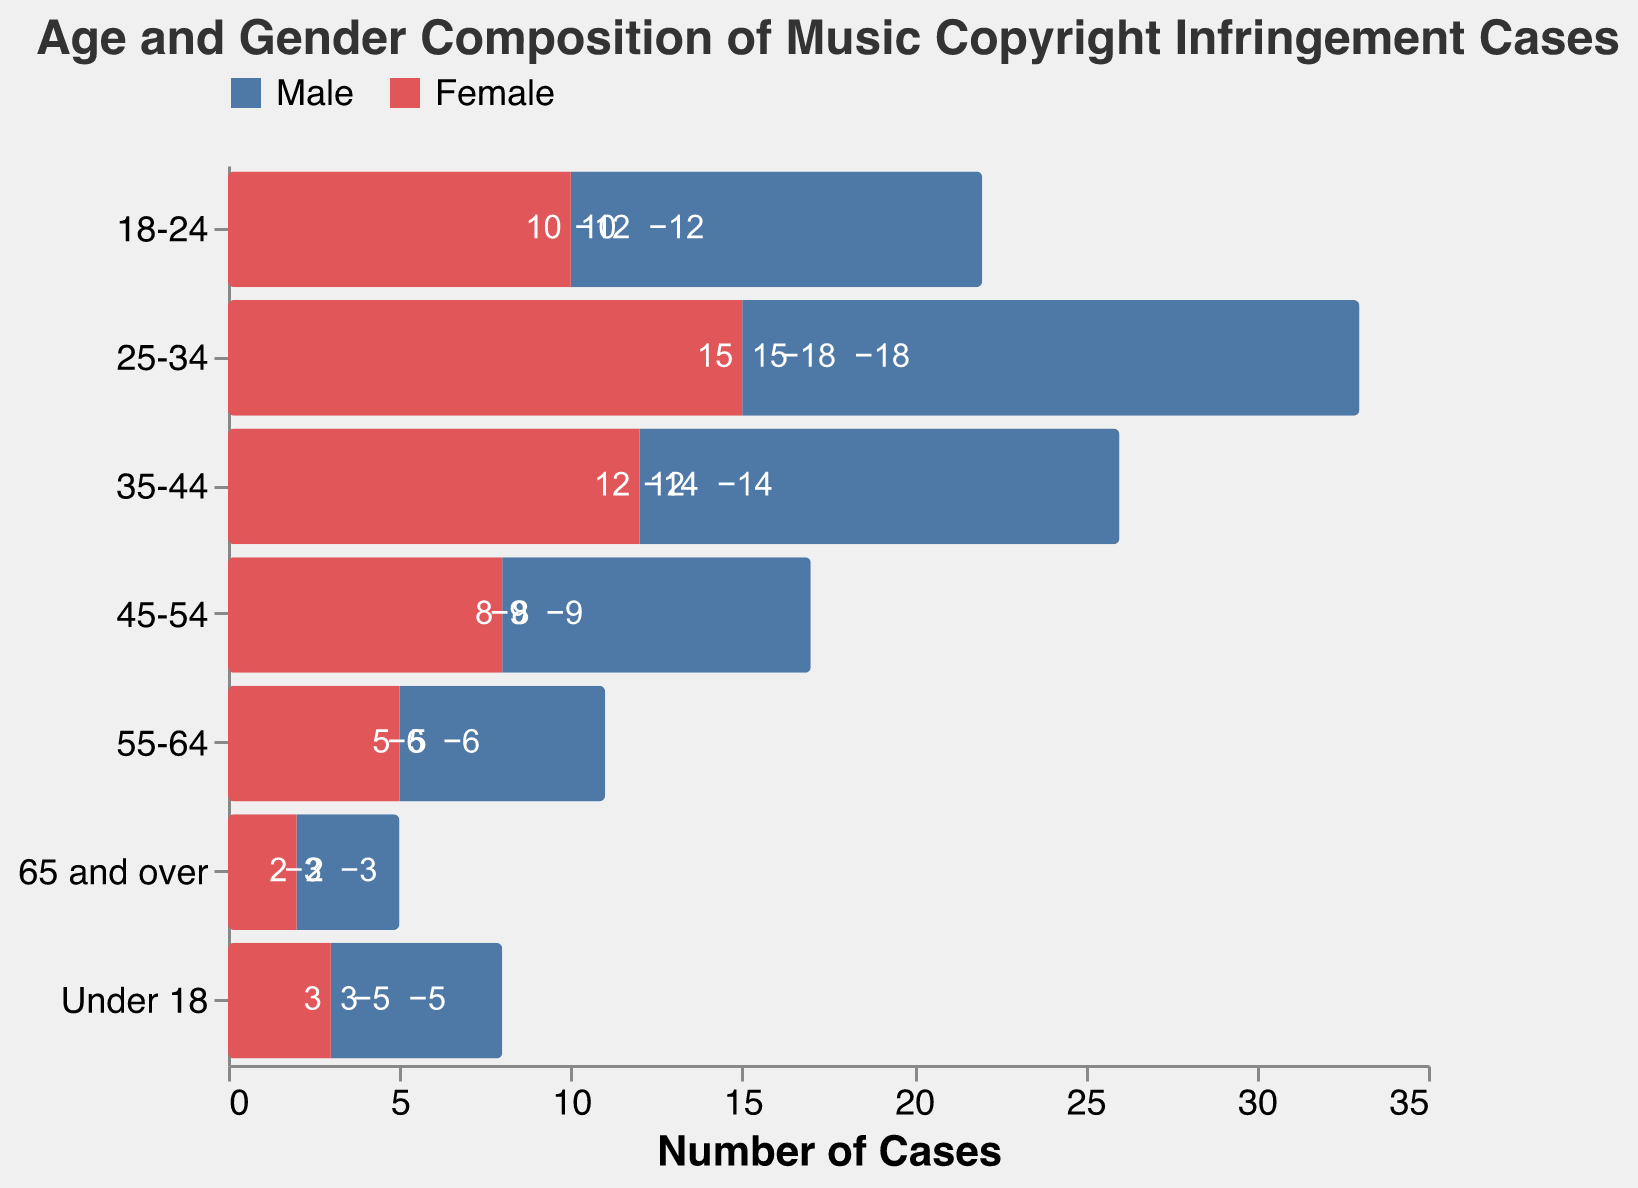What is the title of the figure? The title of the figure is located at the top and reads, "Age and Gender Composition of Music Copyright Infringement Cases."
Answer: Age and Gender Composition of Music Copyright Infringement Cases What age group has the highest number of male copyright infringement cases? The age group with the highest number of male copyright infringement cases can be seen by comparing the length of the bars representing males. The 25-34 age group has the longest bar for males, representing -18 cases.
Answer: 25-34 How many copyright infringement cases involve females aged 18-24? The bar representing females aged 18-24 shows a positive value of 10.
Answer: 10 What is the difference in the number of copyright infringement cases involving males and females in the 25-34 age group? For the 25-34 age group, males have -18 cases and females have 15 cases. The difference is calculated as 18 - 15.
Answer: 3 Which gender has more copyright infringement cases in the 45-54 age group? By comparing the bar lengths and values, males have -9 cases and females have 8 cases in the 45-54 age group. Males have more cases considering the absolute values.
Answer: Male Compare the number of cases in the 'Under 18' category between males and females. Which gender has fewer cases? The 'Under 18' category shows males with -5 cases and females with 3 cases. Males have fewer cases due to the higher absolute value for females.
Answer: Male Which age group has the lowest number of copyright infringement cases involving males? The '65 and over' age group has the shortest bar for males, representing -3 cases.
Answer: 65 and over How many copyright infringement cases involve females aged 35-44? The bar representing females aged 35-44 shows a positive value of 12.
Answer: 12 